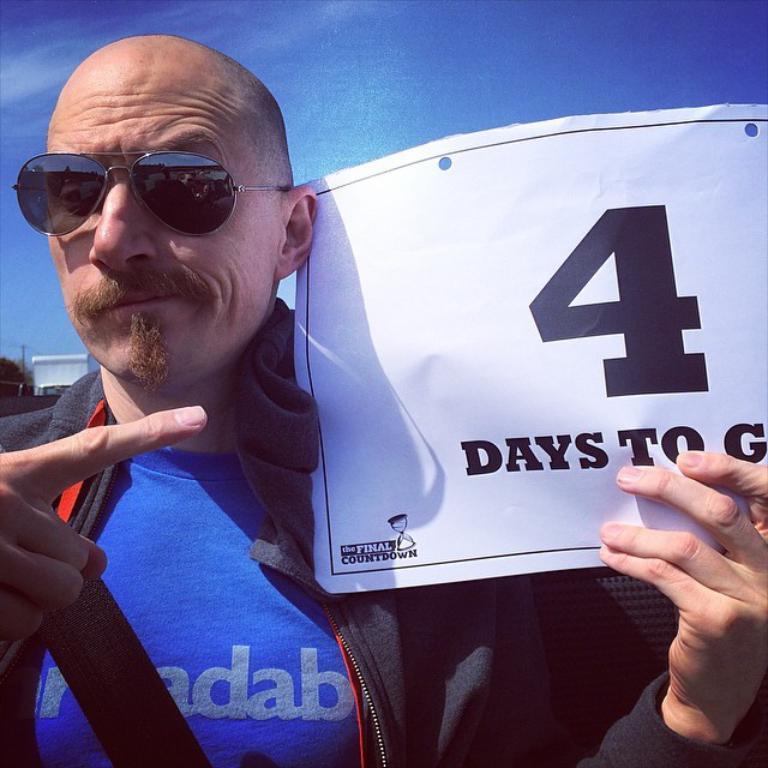In one or two sentences, can you explain what this image depicts? In this picture we can see a man, he wore spectacles, and he is holding a paper in his hand, in the background we can see a pole, trees and clouds. 